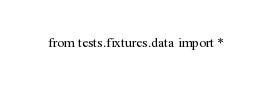<code> <loc_0><loc_0><loc_500><loc_500><_Python_>from tests.fixtures.data import *</code> 